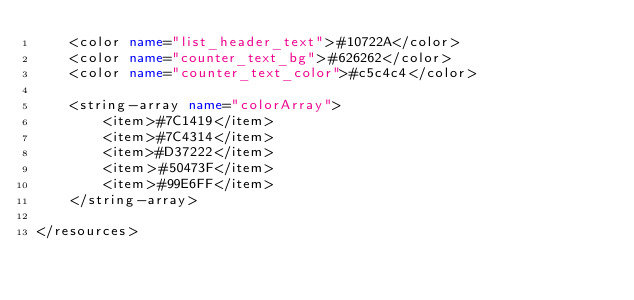<code> <loc_0><loc_0><loc_500><loc_500><_XML_>    <color name="list_header_text">#10722A</color>
    <color name="counter_text_bg">#626262</color>
    <color name="counter_text_color">#c5c4c4</color>

    <string-array name="colorArray">
        <item>#7C1419</item>
        <item>#7C4314</item>
        <item>#D37222</item>
        <item>#50473F</item>
        <item>#99E6FF</item>
    </string-array>

</resources>
</code> 